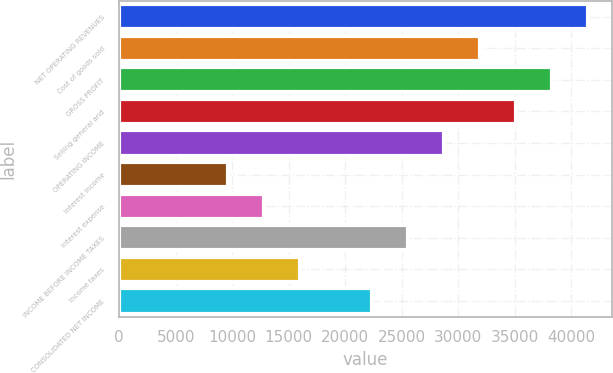<chart> <loc_0><loc_0><loc_500><loc_500><bar_chart><fcel>NET OPERATING REVENUES<fcel>Cost of goods sold<fcel>GROSS PROFIT<fcel>Selling general and<fcel>OPERATING INCOME<fcel>Interest income<fcel>Interest expense<fcel>INCOME BEFORE INCOME TAXES<fcel>Income taxes<fcel>CONSOLIDATED NET INCOME<nl><fcel>41526.4<fcel>31944<fcel>38332.3<fcel>35138.1<fcel>28749.8<fcel>9584.94<fcel>12779.1<fcel>25555.7<fcel>15973.2<fcel>22361.5<nl></chart> 